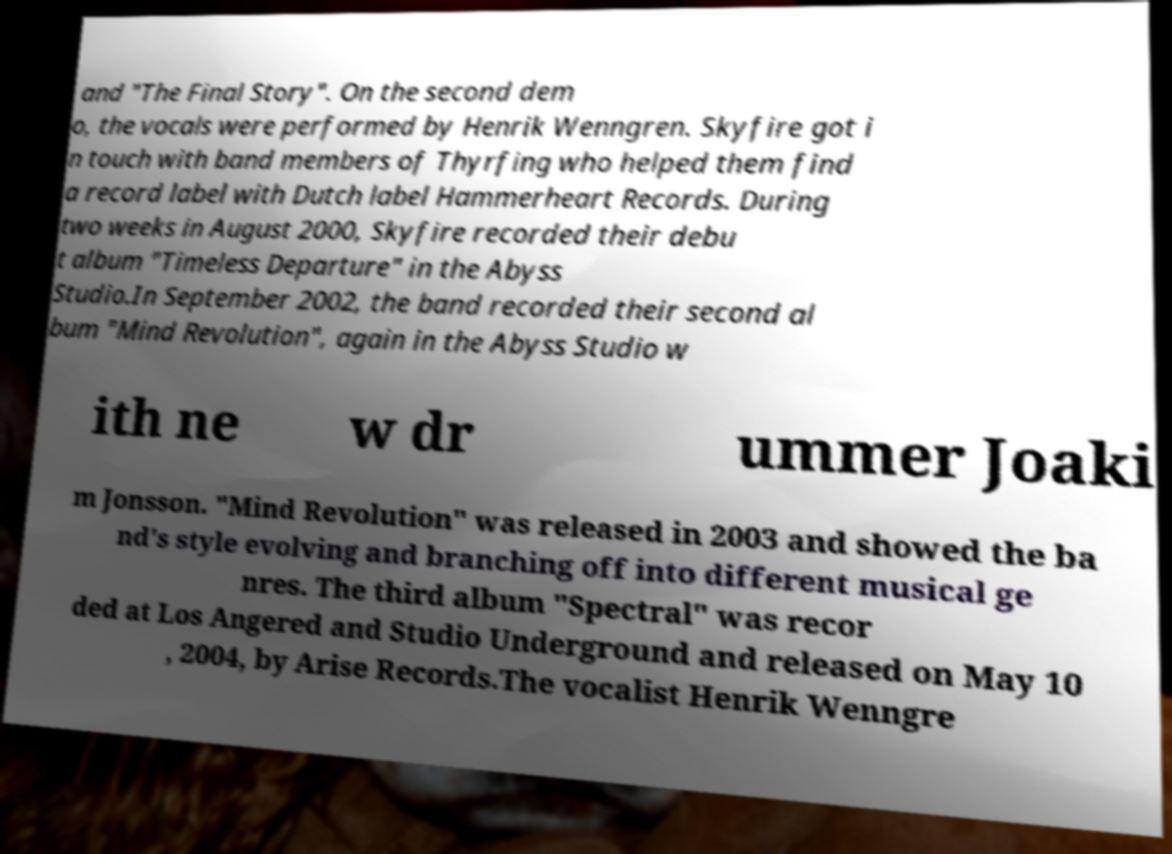There's text embedded in this image that I need extracted. Can you transcribe it verbatim? and "The Final Story". On the second dem o, the vocals were performed by Henrik Wenngren. Skyfire got i n touch with band members of Thyrfing who helped them find a record label with Dutch label Hammerheart Records. During two weeks in August 2000, Skyfire recorded their debu t album "Timeless Departure" in the Abyss Studio.In September 2002, the band recorded their second al bum "Mind Revolution", again in the Abyss Studio w ith ne w dr ummer Joaki m Jonsson. "Mind Revolution" was released in 2003 and showed the ba nd's style evolving and branching off into different musical ge nres. The third album "Spectral" was recor ded at Los Angered and Studio Underground and released on May 10 , 2004, by Arise Records.The vocalist Henrik Wenngre 